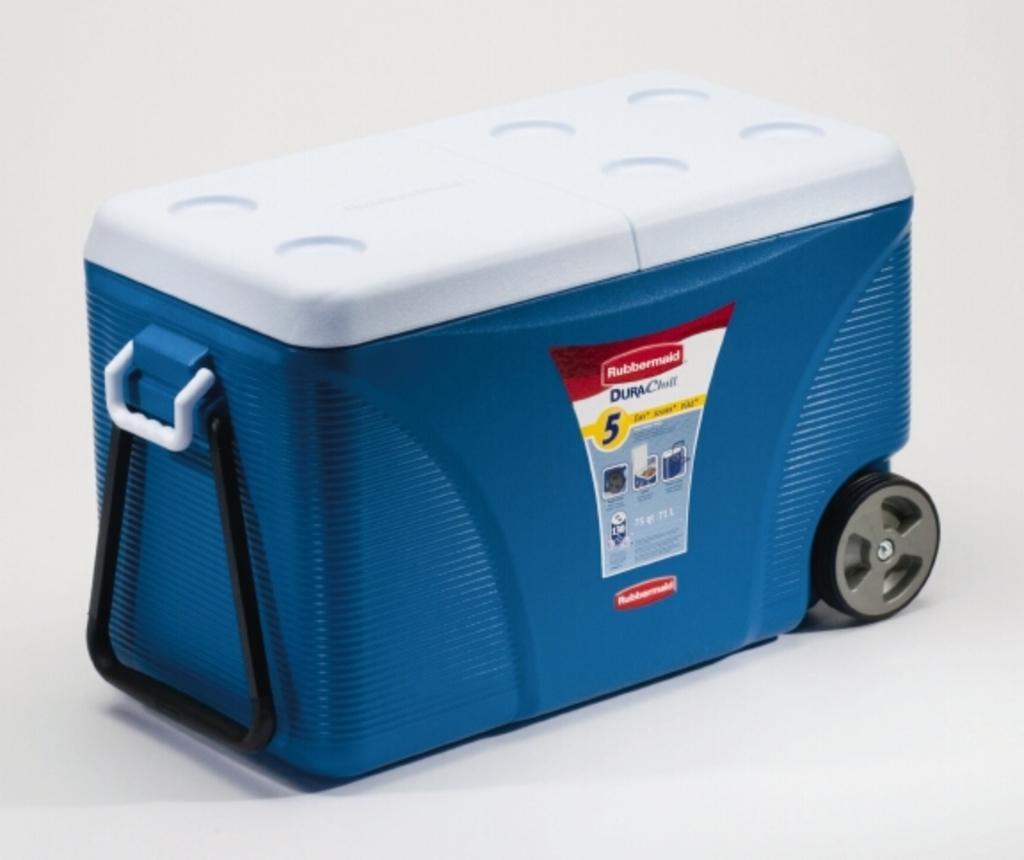Could you give a brief overview of what you see in this image? In this picture I can observe a blue color box. I can observe white and black color holders fixed to this box. There is white color cap on the box. The box is placed on the floor. The background is in white color. 